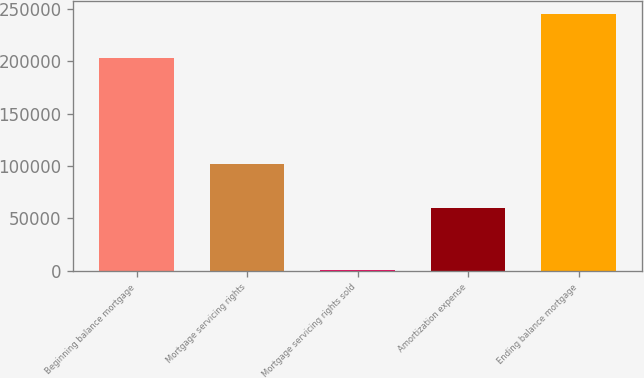Convert chart. <chart><loc_0><loc_0><loc_500><loc_500><bar_chart><fcel>Beginning balance mortgage<fcel>Mortgage servicing rights<fcel>Mortgage servicing rights sold<fcel>Amortization expense<fcel>Ending balance mortgage<nl><fcel>202982<fcel>102132<fcel>783<fcel>59608<fcel>244723<nl></chart> 